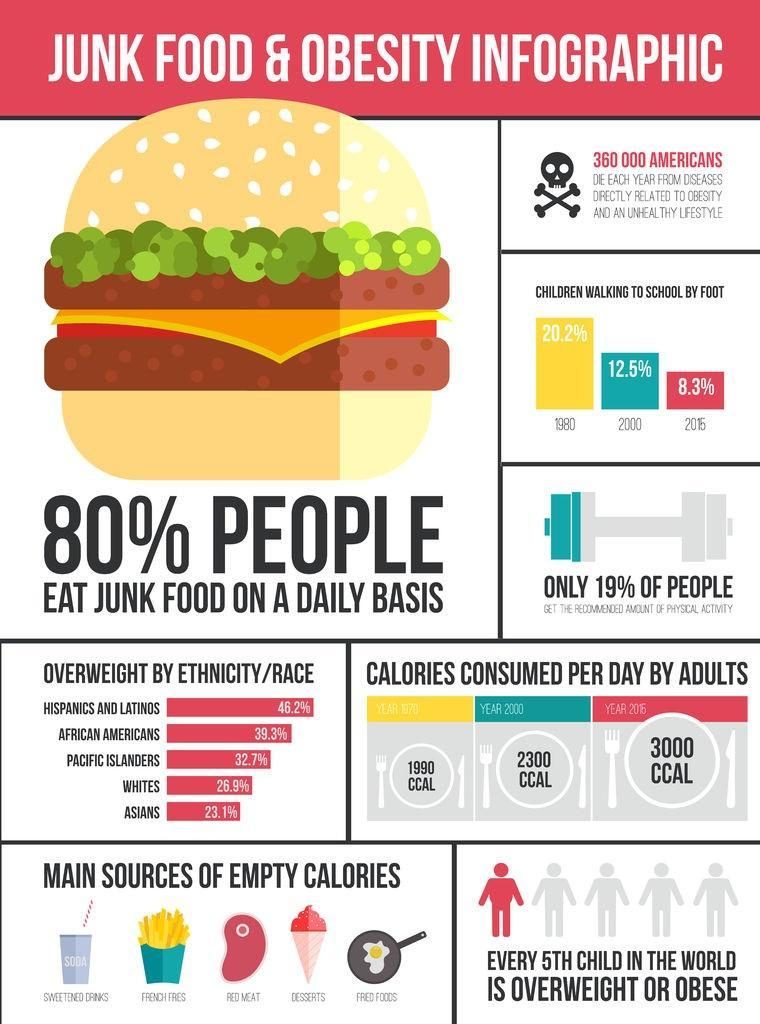Which ethnic group in America has 39.3% of overweight people?
Answer the question with a short phrase. AFRICAN AMERICANS Which ethnic group in America has 23.1% of overweight people? ASIANS What is the amount of calories consumed per day by adults in America in the year 2000? 2300 CCAL Which ethnic group in America has 32.7% of overweight people? PACIFIC ISLANDERS What is the amount of calories consumed per day by adults in America in the year 2016? 3000 CCAL What percentage of children in America go to school by walking in 2000? 12.5% What percentage of whites in America are overweight? 26.9% What percentage of Americans do not get the recommended amount of physical activity? 81% 